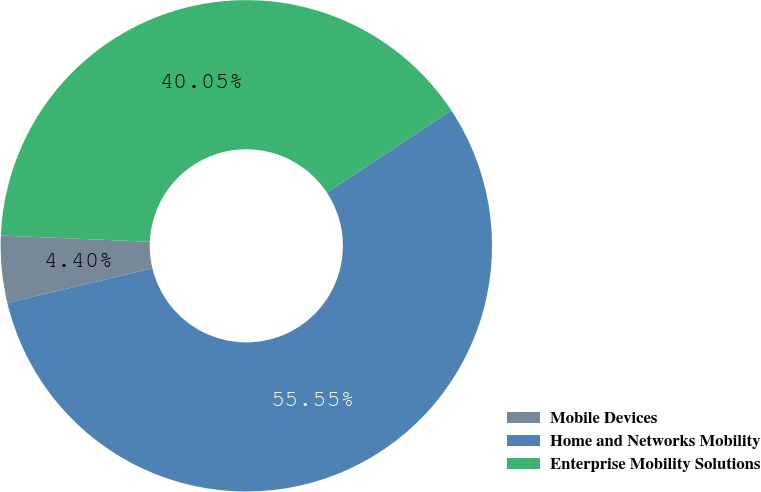<chart> <loc_0><loc_0><loc_500><loc_500><pie_chart><fcel>Mobile Devices<fcel>Home and Networks Mobility<fcel>Enterprise Mobility Solutions<nl><fcel>4.4%<fcel>55.56%<fcel>40.05%<nl></chart> 